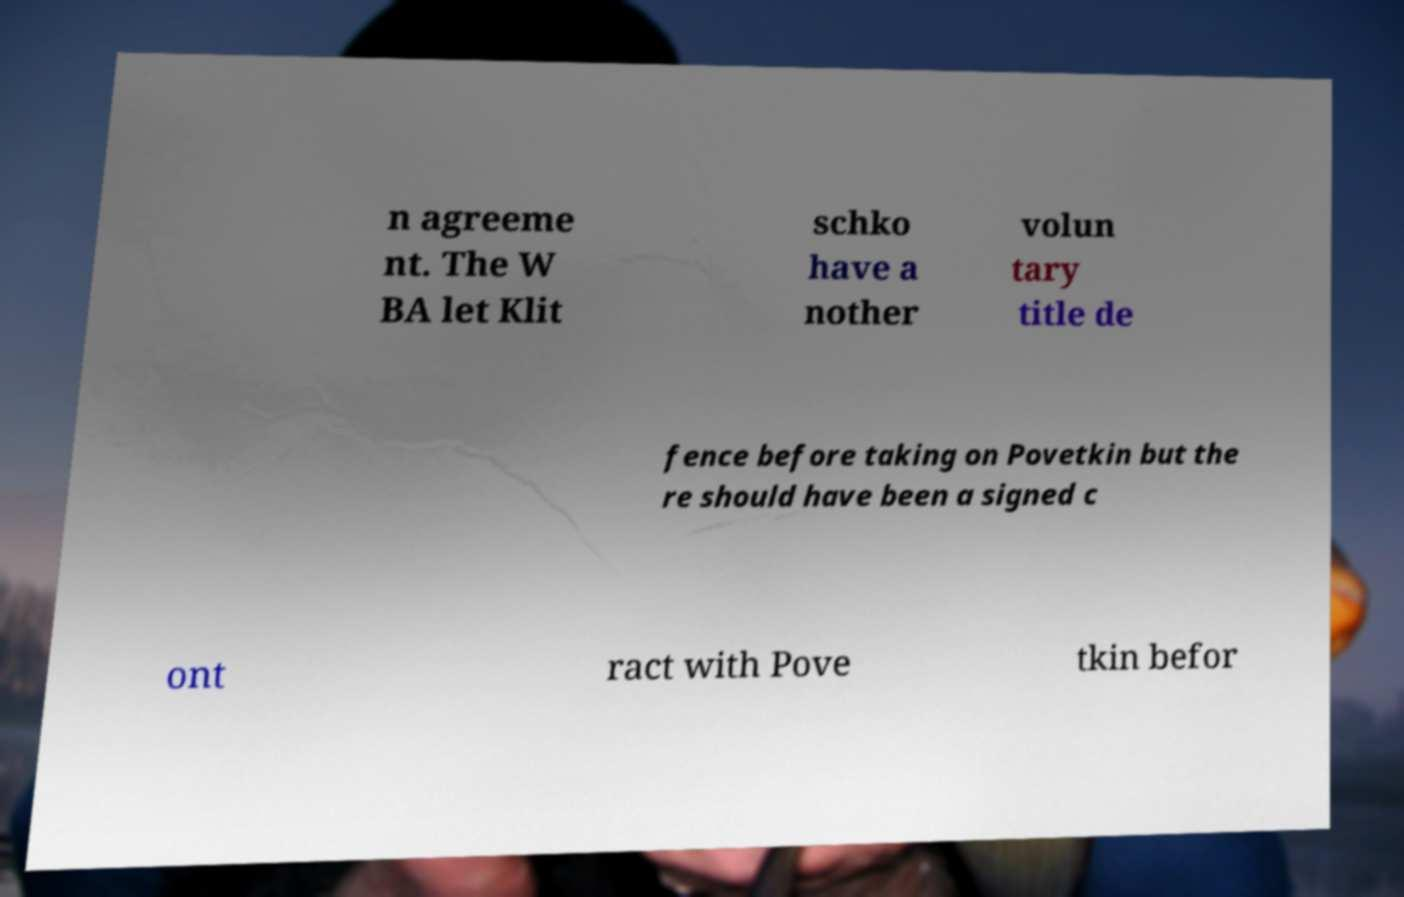Could you assist in decoding the text presented in this image and type it out clearly? n agreeme nt. The W BA let Klit schko have a nother volun tary title de fence before taking on Povetkin but the re should have been a signed c ont ract with Pove tkin befor 